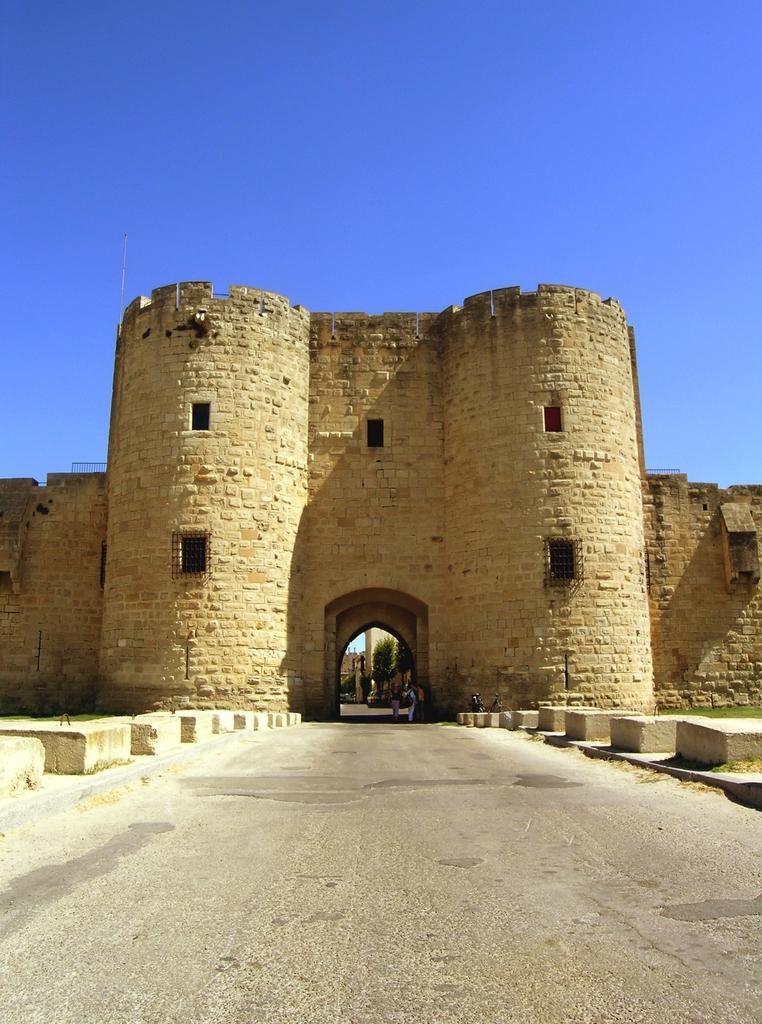Please provide a concise description of this image. In this picture we can observe an entrance of the fort. We can observe cream color wall. There is a road in front of this entrance. In the background there is a sky. 